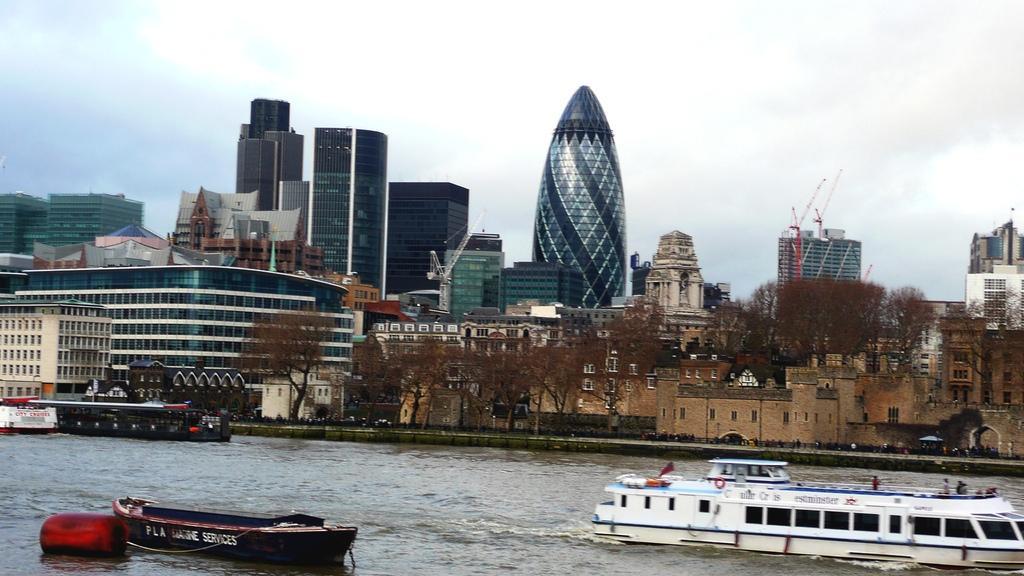Describe this image in one or two sentences. In this image I can see at the bottom there are boats in this water, in the middle there are trees and buildings. At the top it is the sky. 